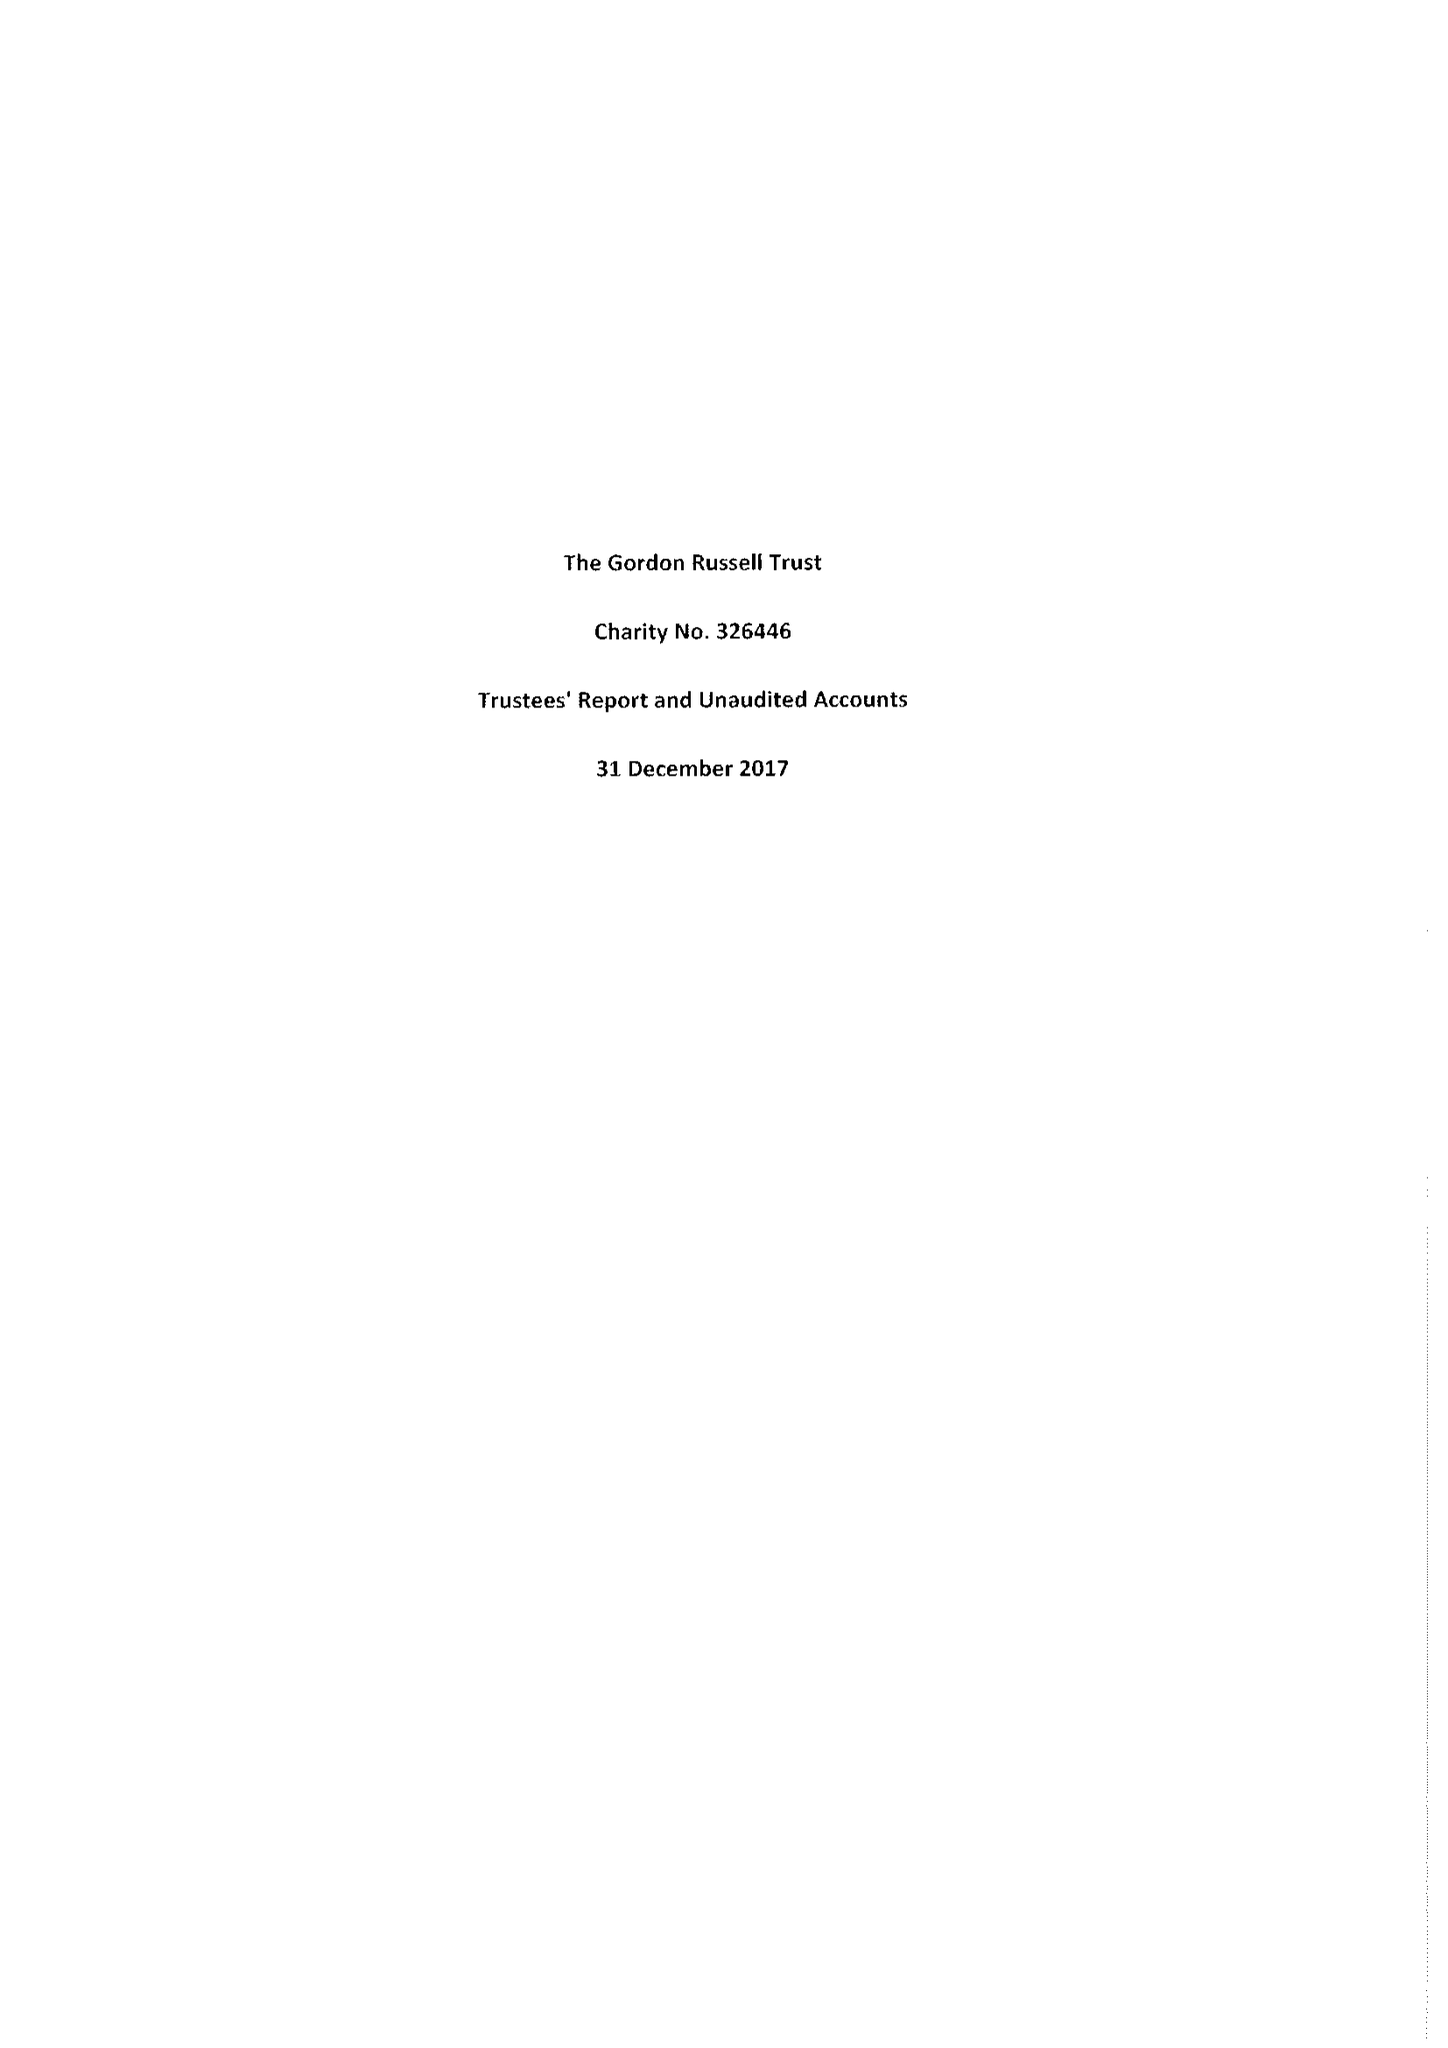What is the value for the report_date?
Answer the question using a single word or phrase. 2017-12-31 